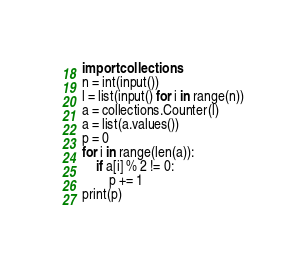Convert code to text. <code><loc_0><loc_0><loc_500><loc_500><_Python_>import collections
n = int(input())
l = list(input() for i in range(n))
a = collections.Counter(l)
a = list(a.values())
p = 0
for i in range(len(a)):
    if a[i] % 2 != 0:
        p += 1
print(p)</code> 